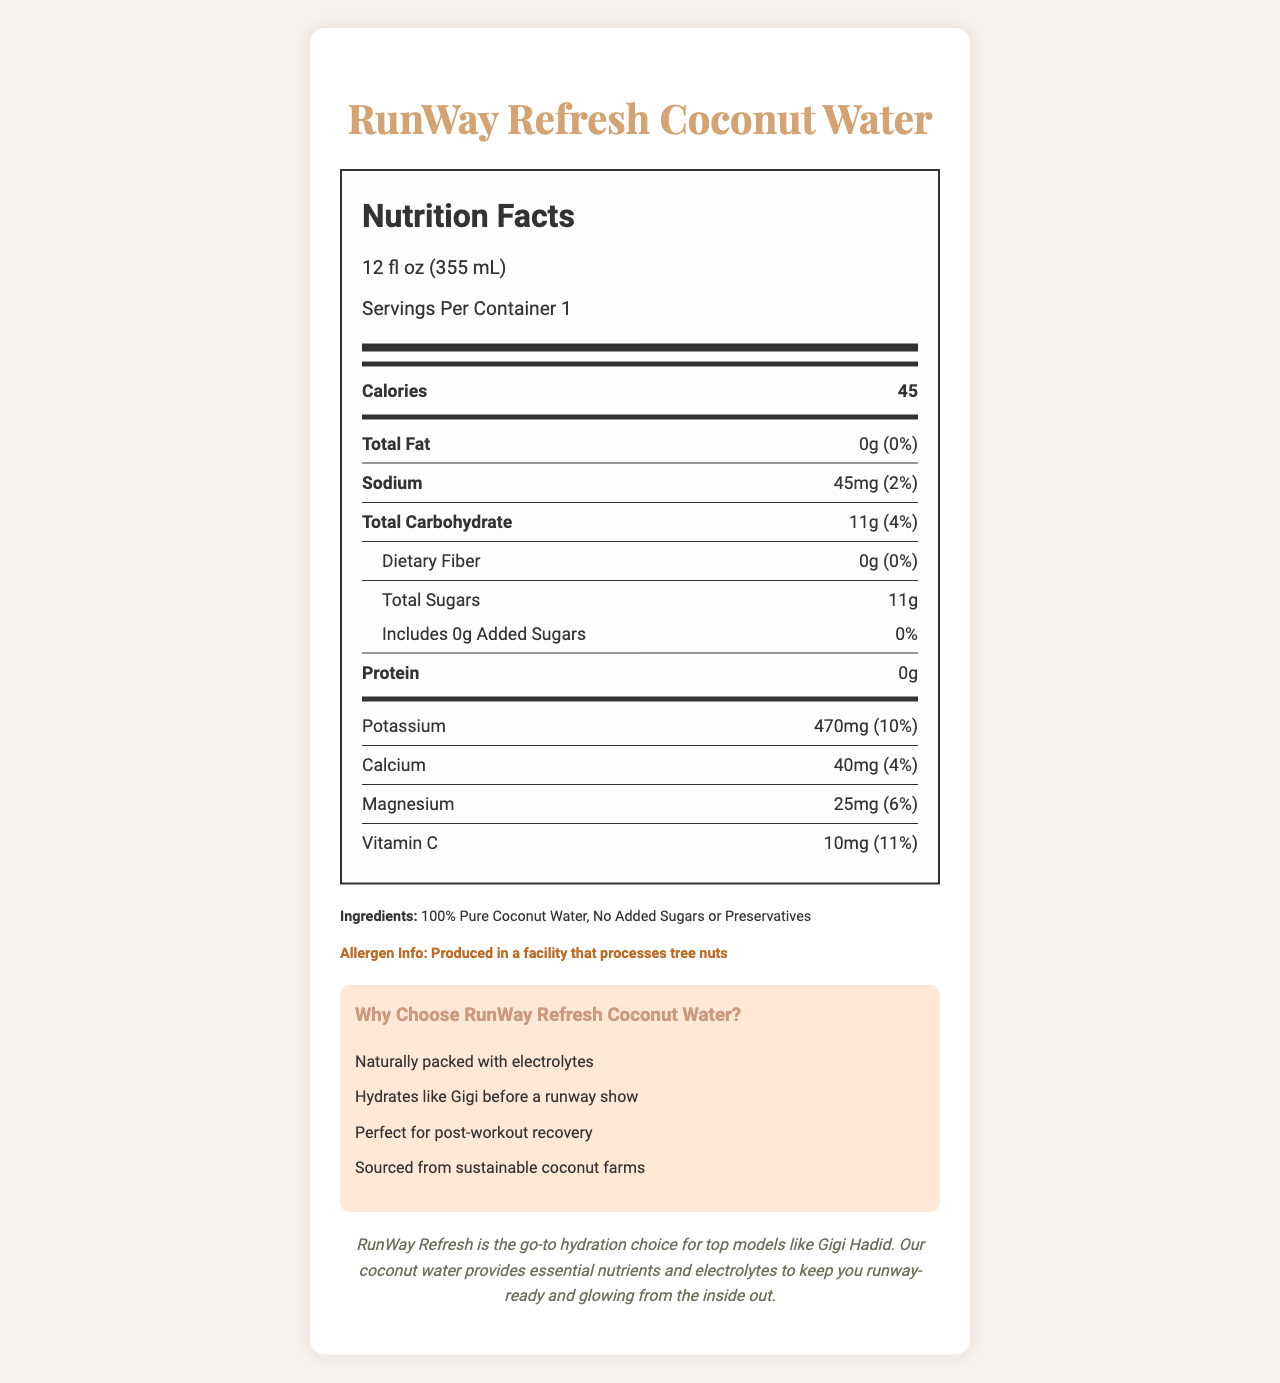what is the product name? The product name is clearly stated at the top of the document in the header and repeated in sections throughout the document.
Answer: RunWay Refresh Coconut Water how many calories are in a serving? The calories per serving are explicitly listed as 45 in the nutrition label.
Answer: 45 which ingredients are used in this beverage? The ingredients are listed in the ingredients section of the document.
Answer: 100% Pure Coconut Water, No Added Sugars or Preservatives how much protein does the beverage contain? The nutrition label shows that the protein content is 0 grams.
Answer: 0g what is the serving size for this product? The serving size is mentioned at the top of the nutrition facts section as 12 fl oz (355 mL).
Answer: 12 fl oz (355 mL) what minerals and vitamins are present in the beverage? A. Calcium, Potassium, Magnesium, Vitamin C B. Calcium, Iron, Magnesium, Vitamin C C. Calcium, Potassium, Magnesium, Vitamin D The nutrition facts label lists Calcium, Potassium, Magnesium, and Vitamin C as the minerals and vitamins present.
Answer: A what makes this coconut water suitable for post-workout recovery? A. High protein content B. Hydrates like Gigi before a runway show C. Naturally packed with electrolytes The additional information section mentions that it is naturally packed with electrolytes, which makes it suitable for post-workout recovery.
Answer: C does the product contain any added sugars? The nutrition label shows "Includes 0g Added Sugars," and the ingredients section confirms "No Added Sugars or Preservatives."
Answer: No is this product specially produced for people with tree nut allergies? The allergen information states that it is produced in a facility that processes tree nuts, which could be a concern for people with tree nut allergies.
Answer: No what is the main idea of the document? The document is comprehensive about the product, including a nutrition facts label, ingredient details, allergen information, and benefits, making it clear that the focus is on promoting the health benefits of the coconut water.
Answer: The document provides detailed nutrition facts and additional information about RunWay Refresh Coconut Water, highlighting its ingredients, nutritional benefits, suitability for models like Gigi Hadid, and its use for hydration and post-workout recovery. do we know where the coconut farms are located? The document mentions that the coconut water is sourced from sustainable coconut farms, but it does not provide specific locations for these farms.
Answer: Not enough information 